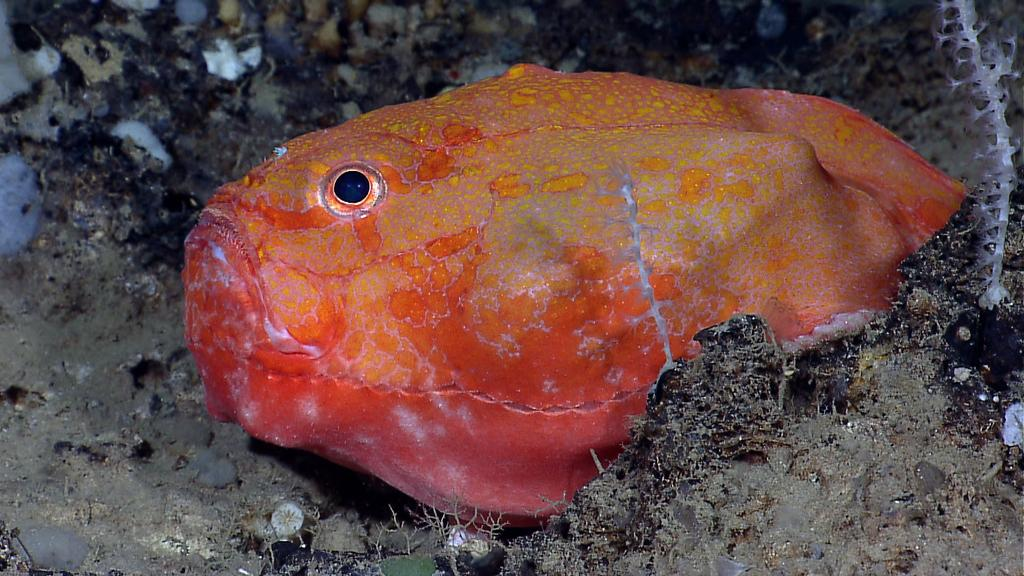What type of animal is in the image? There is a fish in the image. What colors can be seen on the fish? The fish has orange and yellow colors. What is the color of the surface in the image? The surface in the image has grey and black colors. Where is the nest of the fish located in the image? There is no nest present in the image, as fish do not build nests. 